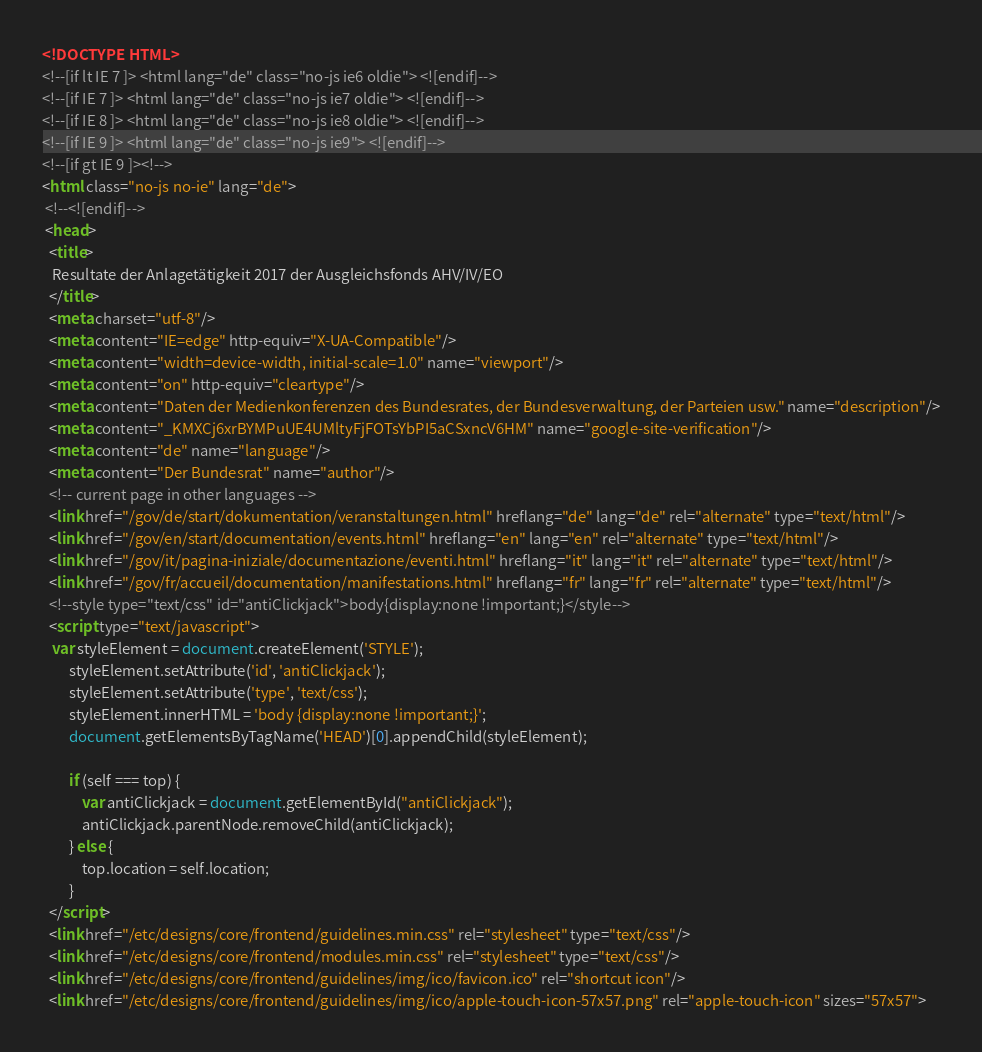<code> <loc_0><loc_0><loc_500><loc_500><_HTML_><!DOCTYPE HTML>
<!--[if lt IE 7 ]> <html lang="de" class="no-js ie6 oldie"> <![endif]-->
<!--[if IE 7 ]> <html lang="de" class="no-js ie7 oldie"> <![endif]-->
<!--[if IE 8 ]> <html lang="de" class="no-js ie8 oldie"> <![endif]-->
<!--[if IE 9 ]> <html lang="de" class="no-js ie9"> <![endif]-->
<!--[if gt IE 9 ]><!-->
<html class="no-js no-ie" lang="de">
 <!--<![endif]-->
 <head>
  <title>
   Resultate der Anlagetätigkeit 2017 der Ausgleichsfonds AHV/IV/EO
  </title>
  <meta charset="utf-8"/>
  <meta content="IE=edge" http-equiv="X-UA-Compatible"/>
  <meta content="width=device-width, initial-scale=1.0" name="viewport"/>
  <meta content="on" http-equiv="cleartype"/>
  <meta content="Daten der Medienkonferenzen des Bundesrates, der Bundesverwaltung, der Parteien usw." name="description"/>
  <meta content="_KMXCj6xrBYMPuUE4UMltyFjFOTsYbPI5aCSxncV6HM" name="google-site-verification"/>
  <meta content="de" name="language"/>
  <meta content="Der Bundesrat" name="author"/>
  <!-- current page in other languages -->
  <link href="/gov/de/start/dokumentation/veranstaltungen.html" hreflang="de" lang="de" rel="alternate" type="text/html"/>
  <link href="/gov/en/start/documentation/events.html" hreflang="en" lang="en" rel="alternate" type="text/html"/>
  <link href="/gov/it/pagina-iniziale/documentazione/eventi.html" hreflang="it" lang="it" rel="alternate" type="text/html"/>
  <link href="/gov/fr/accueil/documentation/manifestations.html" hreflang="fr" lang="fr" rel="alternate" type="text/html"/>
  <!--style type="text/css" id="antiClickjack">body{display:none !important;}</style-->
  <script type="text/javascript">
   var styleElement = document.createElement('STYLE');
		styleElement.setAttribute('id', 'antiClickjack');
		styleElement.setAttribute('type', 'text/css');
		styleElement.innerHTML = 'body {display:none !important;}';
		document.getElementsByTagName('HEAD')[0].appendChild(styleElement);

		if (self === top) {
			var antiClickjack = document.getElementById("antiClickjack");
			antiClickjack.parentNode.removeChild(antiClickjack);
		} else {
			top.location = self.location;
		}
  </script>
  <link href="/etc/designs/core/frontend/guidelines.min.css" rel="stylesheet" type="text/css"/>
  <link href="/etc/designs/core/frontend/modules.min.css" rel="stylesheet" type="text/css"/>
  <link href="/etc/designs/core/frontend/guidelines/img/ico/favicon.ico" rel="shortcut icon"/>
  <link href="/etc/designs/core/frontend/guidelines/img/ico/apple-touch-icon-57x57.png" rel="apple-touch-icon" sizes="57x57"></code> 